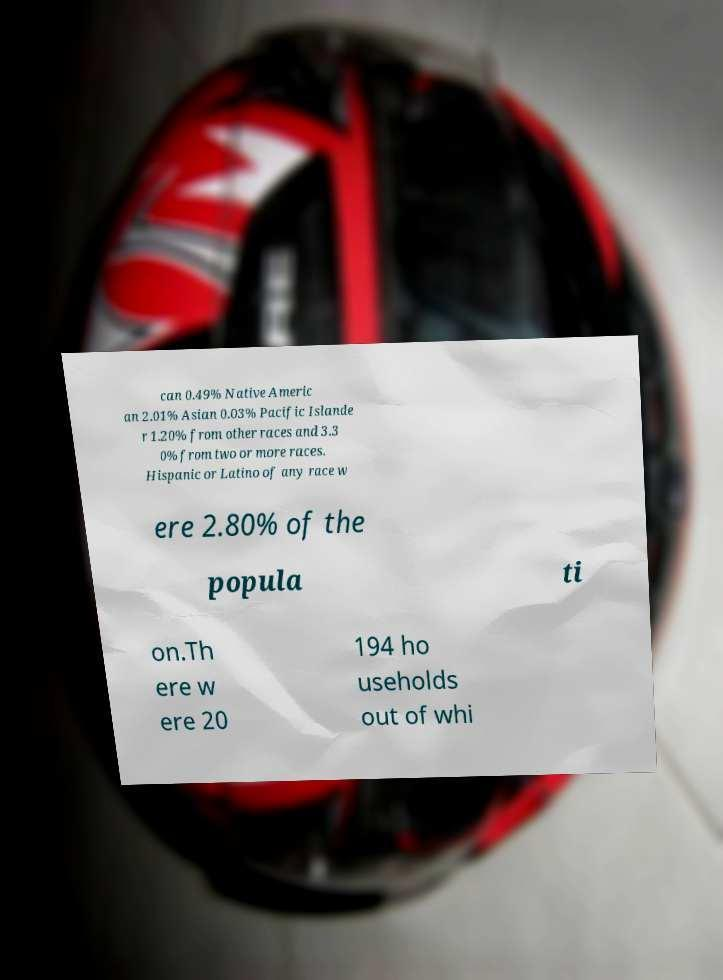Can you accurately transcribe the text from the provided image for me? can 0.49% Native Americ an 2.01% Asian 0.03% Pacific Islande r 1.20% from other races and 3.3 0% from two or more races. Hispanic or Latino of any race w ere 2.80% of the popula ti on.Th ere w ere 20 194 ho useholds out of whi 